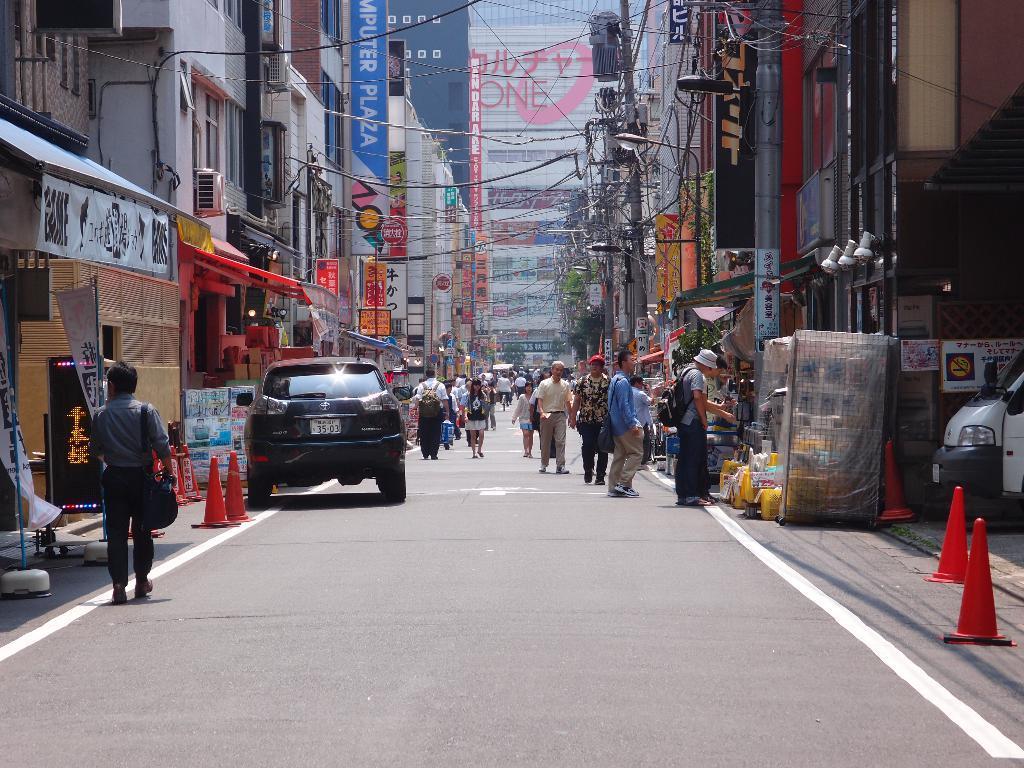In one or two sentences, can you explain what this image depicts? In this image I can see few buildings, windows, few stores, traffic-cones, vehicles, few colorful boards, current poles, light poles, wires, few people are walking and few people are standing. Few people are wearing bags and few objects on the road. 